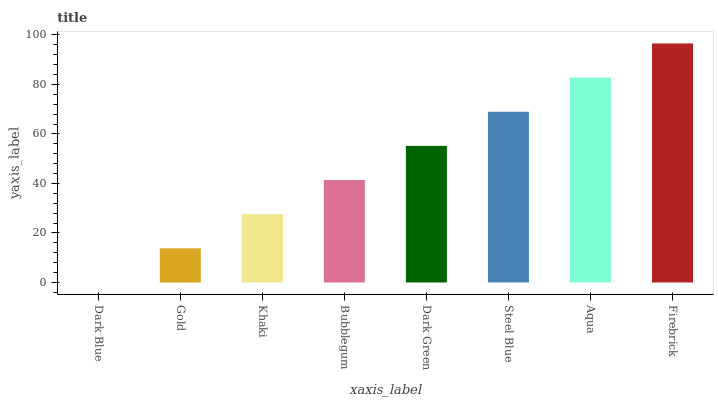Is Dark Blue the minimum?
Answer yes or no. Yes. Is Firebrick the maximum?
Answer yes or no. Yes. Is Gold the minimum?
Answer yes or no. No. Is Gold the maximum?
Answer yes or no. No. Is Gold greater than Dark Blue?
Answer yes or no. Yes. Is Dark Blue less than Gold?
Answer yes or no. Yes. Is Dark Blue greater than Gold?
Answer yes or no. No. Is Gold less than Dark Blue?
Answer yes or no. No. Is Dark Green the high median?
Answer yes or no. Yes. Is Bubblegum the low median?
Answer yes or no. Yes. Is Gold the high median?
Answer yes or no. No. Is Gold the low median?
Answer yes or no. No. 